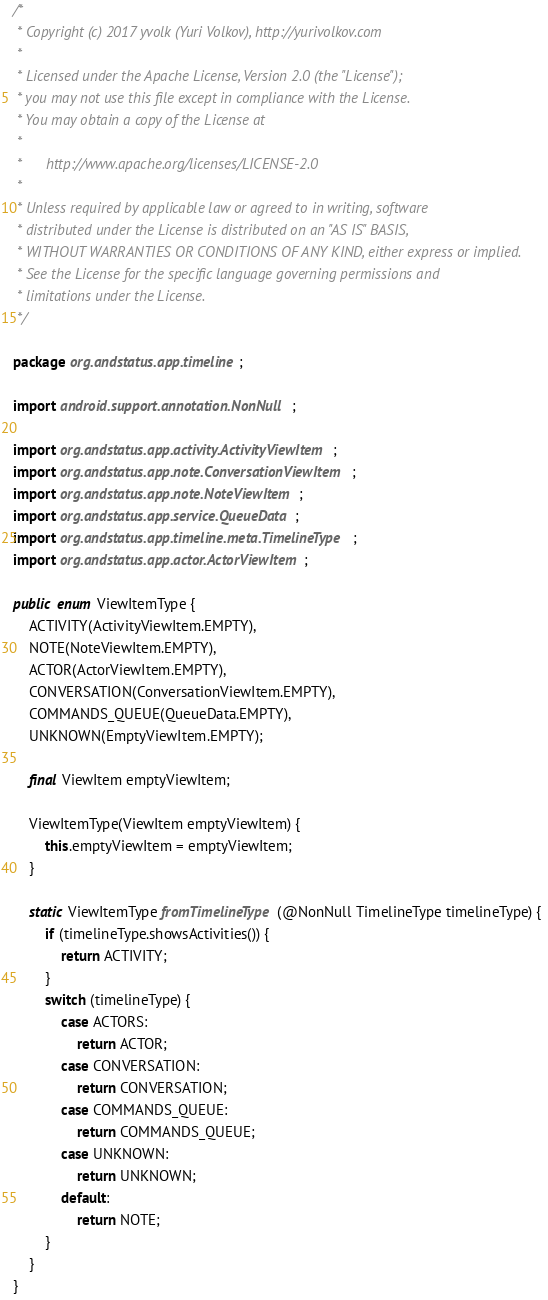<code> <loc_0><loc_0><loc_500><loc_500><_Java_>/*
 * Copyright (c) 2017 yvolk (Yuri Volkov), http://yurivolkov.com
 *
 * Licensed under the Apache License, Version 2.0 (the "License");
 * you may not use this file except in compliance with the License.
 * You may obtain a copy of the License at
 *
 *      http://www.apache.org/licenses/LICENSE-2.0
 *
 * Unless required by applicable law or agreed to in writing, software
 * distributed under the License is distributed on an "AS IS" BASIS,
 * WITHOUT WARRANTIES OR CONDITIONS OF ANY KIND, either express or implied.
 * See the License for the specific language governing permissions and
 * limitations under the License.
 */

package org.andstatus.app.timeline;

import android.support.annotation.NonNull;

import org.andstatus.app.activity.ActivityViewItem;
import org.andstatus.app.note.ConversationViewItem;
import org.andstatus.app.note.NoteViewItem;
import org.andstatus.app.service.QueueData;
import org.andstatus.app.timeline.meta.TimelineType;
import org.andstatus.app.actor.ActorViewItem;

public enum ViewItemType {
    ACTIVITY(ActivityViewItem.EMPTY),
    NOTE(NoteViewItem.EMPTY),
    ACTOR(ActorViewItem.EMPTY),
    CONVERSATION(ConversationViewItem.EMPTY),
    COMMANDS_QUEUE(QueueData.EMPTY),
    UNKNOWN(EmptyViewItem.EMPTY);

    final ViewItem emptyViewItem;

    ViewItemType(ViewItem emptyViewItem) {
        this.emptyViewItem = emptyViewItem;
    }

    static ViewItemType fromTimelineType(@NonNull TimelineType timelineType) {
        if (timelineType.showsActivities()) {
            return ACTIVITY;
        }
        switch (timelineType) {
            case ACTORS:
                return ACTOR;
            case CONVERSATION:
                return CONVERSATION;
            case COMMANDS_QUEUE:
                return COMMANDS_QUEUE;
            case UNKNOWN:
                return UNKNOWN;
            default:
                return NOTE;
        }
    }
}
</code> 